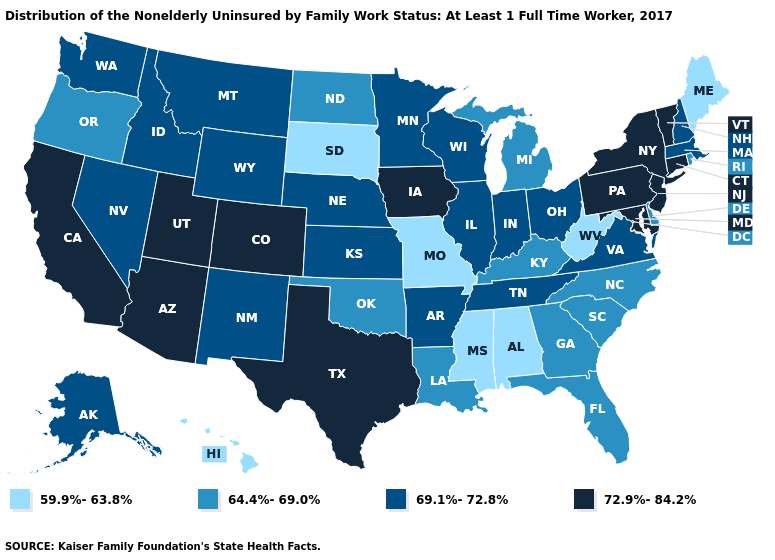Does Maryland have a higher value than Colorado?
Write a very short answer. No. Does the map have missing data?
Answer briefly. No. What is the highest value in states that border Massachusetts?
Write a very short answer. 72.9%-84.2%. Among the states that border Vermont , which have the lowest value?
Quick response, please. Massachusetts, New Hampshire. Does Pennsylvania have the highest value in the USA?
Short answer required. Yes. Does the first symbol in the legend represent the smallest category?
Write a very short answer. Yes. Which states have the highest value in the USA?
Answer briefly. Arizona, California, Colorado, Connecticut, Iowa, Maryland, New Jersey, New York, Pennsylvania, Texas, Utah, Vermont. Does Rhode Island have the highest value in the USA?
Give a very brief answer. No. Name the states that have a value in the range 72.9%-84.2%?
Short answer required. Arizona, California, Colorado, Connecticut, Iowa, Maryland, New Jersey, New York, Pennsylvania, Texas, Utah, Vermont. What is the value of Louisiana?
Answer briefly. 64.4%-69.0%. What is the lowest value in states that border South Carolina?
Give a very brief answer. 64.4%-69.0%. Name the states that have a value in the range 64.4%-69.0%?
Answer briefly. Delaware, Florida, Georgia, Kentucky, Louisiana, Michigan, North Carolina, North Dakota, Oklahoma, Oregon, Rhode Island, South Carolina. Does Washington have the same value as Nevada?
Quick response, please. Yes. What is the highest value in the South ?
Write a very short answer. 72.9%-84.2%. What is the value of Illinois?
Be succinct. 69.1%-72.8%. 